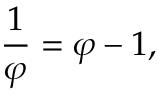Convert formula to latex. <formula><loc_0><loc_0><loc_500><loc_500>{ \frac { 1 } { \varphi } } = \varphi - 1 ,</formula> 